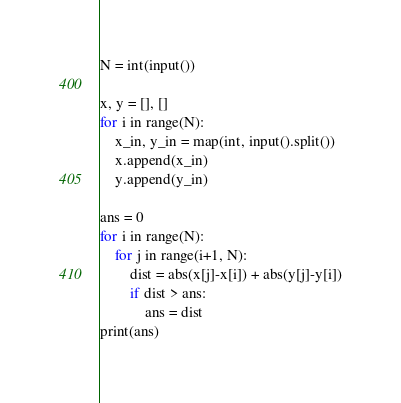<code> <loc_0><loc_0><loc_500><loc_500><_Python_>N = int(input())

x, y = [], []
for i in range(N):
    x_in, y_in = map(int, input().split())
    x.append(x_in)
    y.append(y_in)

ans = 0
for i in range(N):
    for j in range(i+1, N):
        dist = abs(x[j]-x[i]) + abs(y[j]-y[i])
        if dist > ans:
            ans = dist
print(ans)</code> 